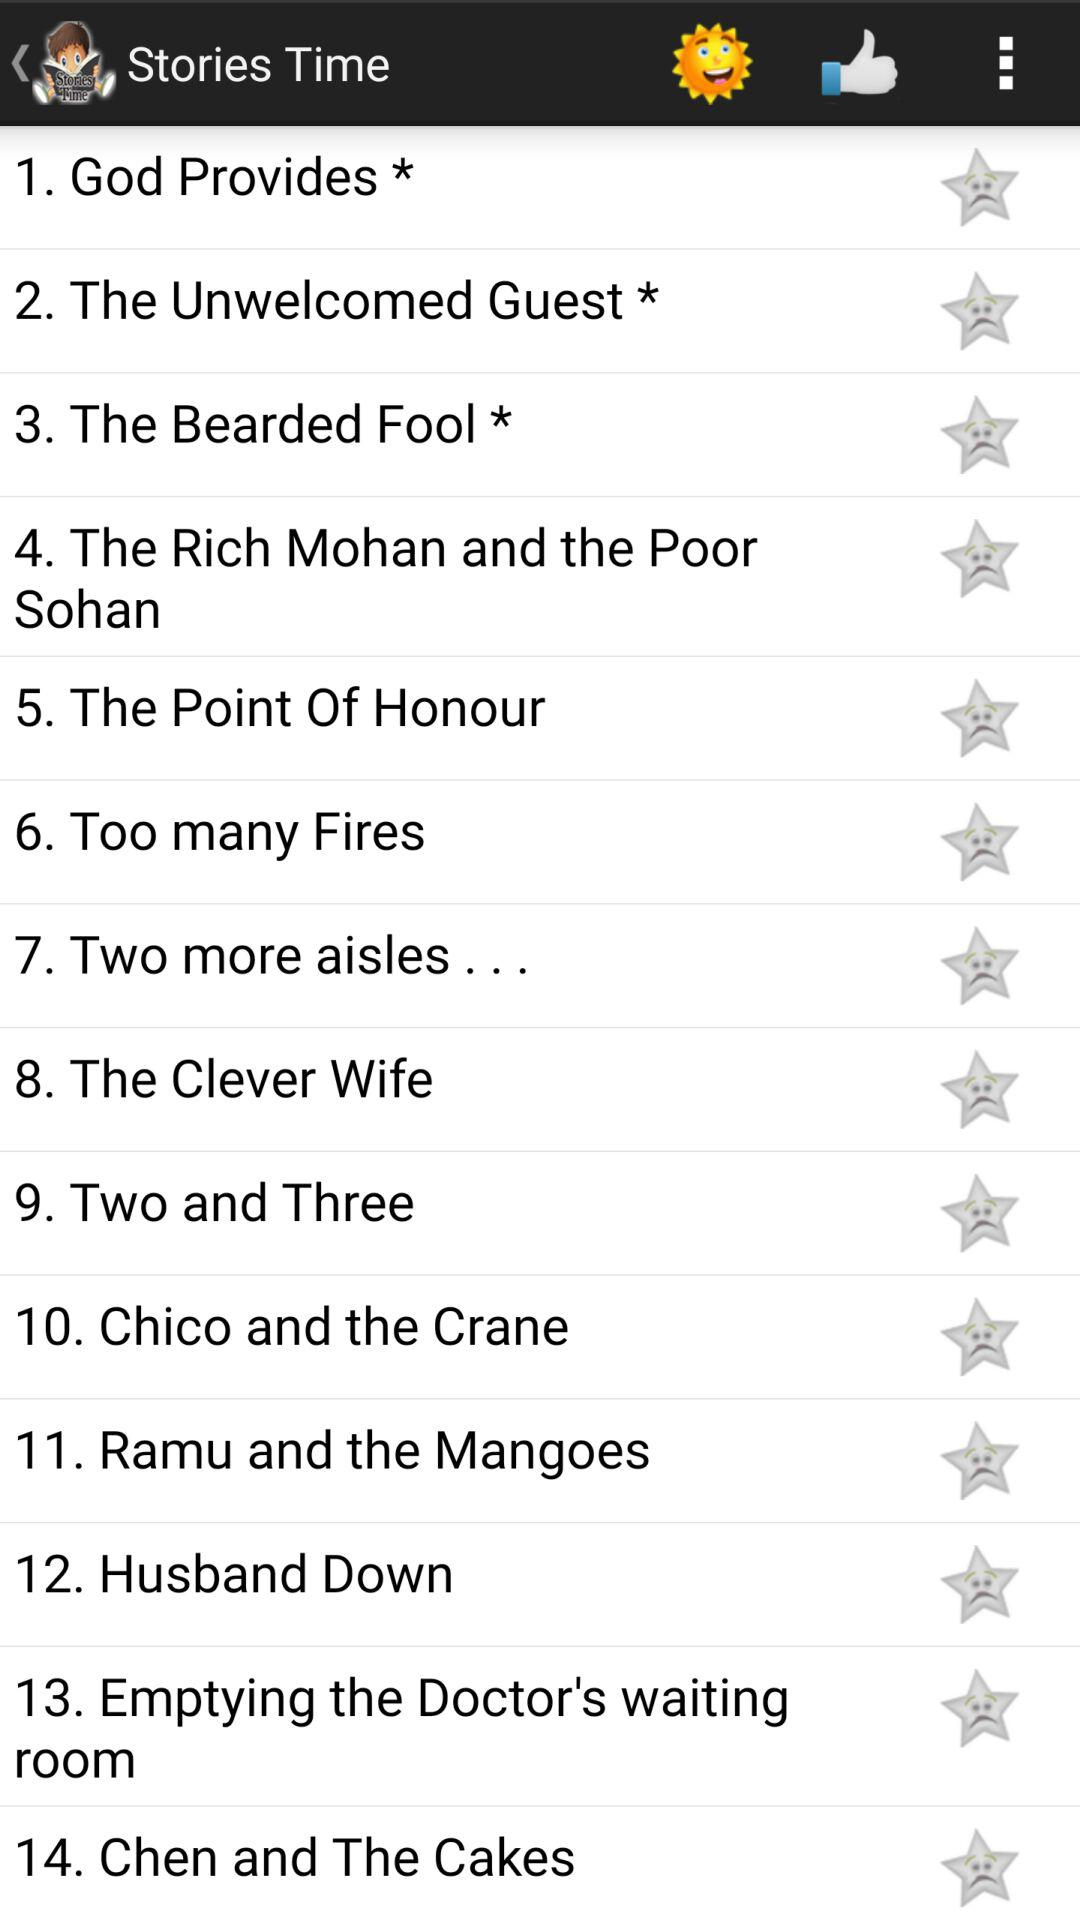What are the names of the stories most often heard by children at bedtime? The names of the stories most often heard by children at bedtime are : "1. God Provides *", "2. The Unwelcomed Guest *", "3. The Bearded Fool *", "4. The Rich Mohan and the Poor Sohan", "5. The Point Of Honour", "6. Too many Fires","7. Two more aisles...","8. The Clever Wife","9. Two and Three", "11. Ramu and the Mangoes", "12. Husband Down", "13. Emptying the Doctor's waiting room", and "14. Chen and The Cakes". 